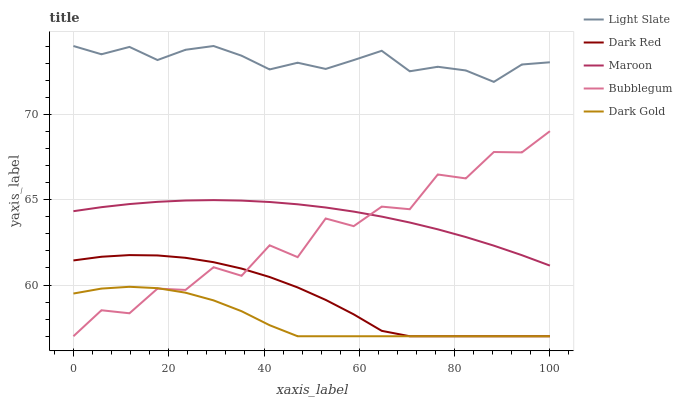Does Dark Gold have the minimum area under the curve?
Answer yes or no. Yes. Does Light Slate have the maximum area under the curve?
Answer yes or no. Yes. Does Dark Red have the minimum area under the curve?
Answer yes or no. No. Does Dark Red have the maximum area under the curve?
Answer yes or no. No. Is Maroon the smoothest?
Answer yes or no. Yes. Is Bubblegum the roughest?
Answer yes or no. Yes. Is Dark Red the smoothest?
Answer yes or no. No. Is Dark Red the roughest?
Answer yes or no. No. Does Dark Red have the lowest value?
Answer yes or no. Yes. Does Maroon have the lowest value?
Answer yes or no. No. Does Light Slate have the highest value?
Answer yes or no. Yes. Does Dark Red have the highest value?
Answer yes or no. No. Is Dark Red less than Light Slate?
Answer yes or no. Yes. Is Maroon greater than Dark Gold?
Answer yes or no. Yes. Does Bubblegum intersect Dark Gold?
Answer yes or no. Yes. Is Bubblegum less than Dark Gold?
Answer yes or no. No. Is Bubblegum greater than Dark Gold?
Answer yes or no. No. Does Dark Red intersect Light Slate?
Answer yes or no. No. 